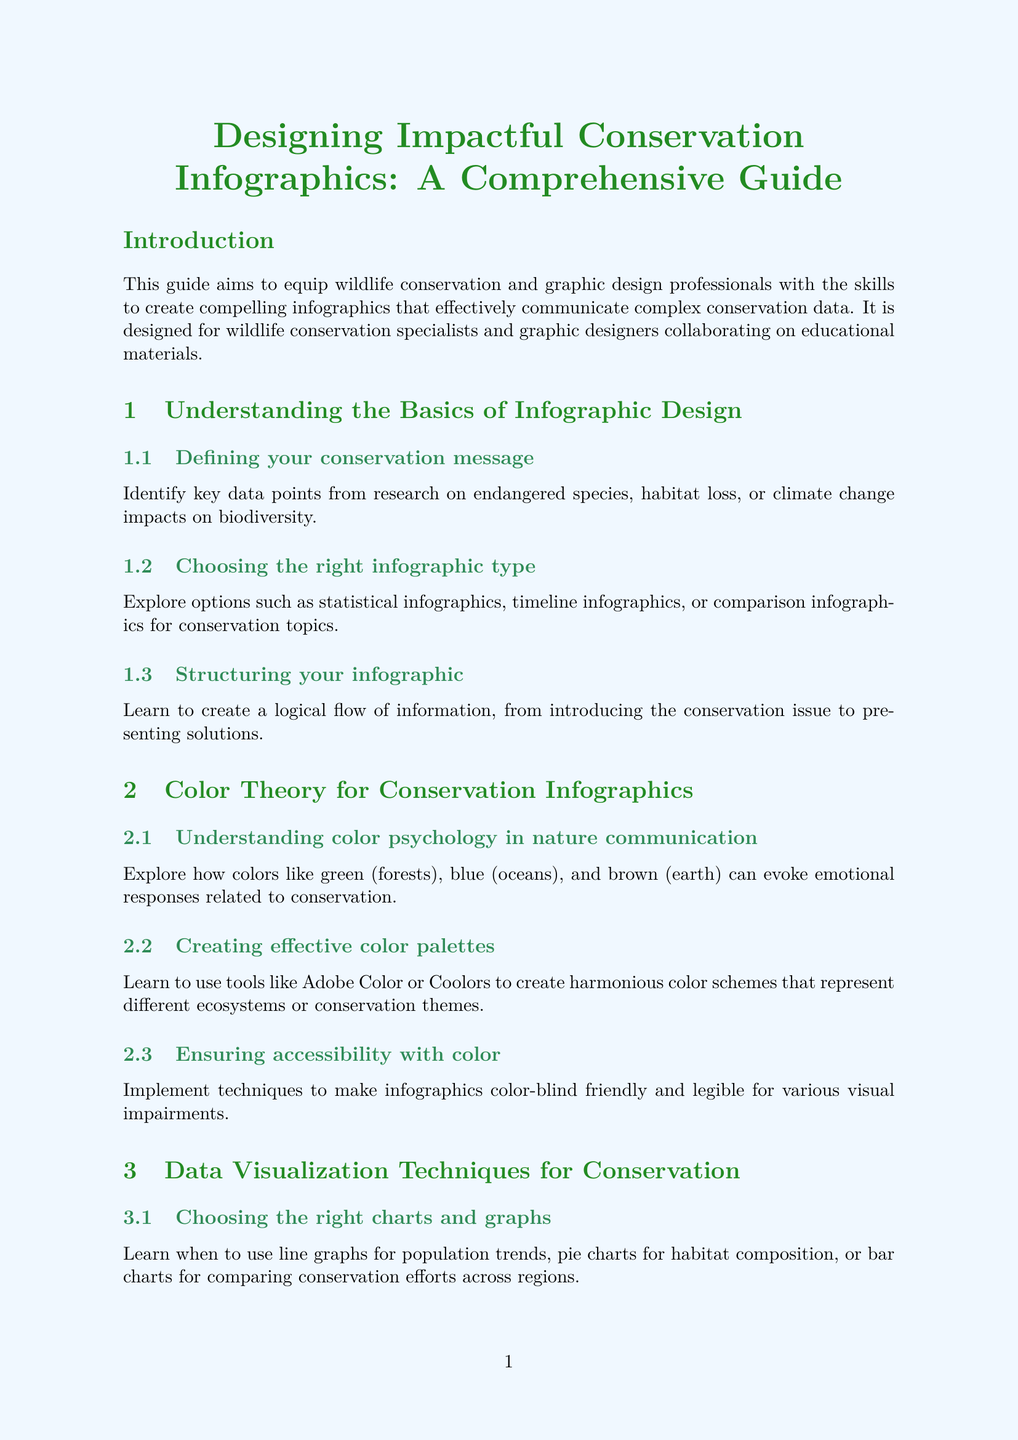What is the title of the manual? The title is stated at the beginning of the document.
Answer: Designing Impactful Conservation Infographics: A Comprehensive Guide Who is the target audience for this manual? The target audience is specified in the introduction section of the document.
Answer: Wildlife conservation specialists and graphic designers Which chapter discusses color psychology? This chapter can be located in the table of contents of the document.
Answer: Color Theory for Conservation Infographics What software is recommended for creating scalable graphics? The section is specifically dedicated to tools and software for infographic creation.
Answer: Adobe Illustrator Which principle is emphasized for balancing text and images? The relevant content is found in the layout and composition chapter.
Answer: Rule of thirds What is the focus of the case study on IUCN? This focus is briefly described in the case studies section of the document.
Answer: Species conservation status How many sections are there in the "Data Visualization Techniques for Conservation" chapter? This can be counted by looking at the sections under this chapter.
Answer: Three Which color is associated with forests in color psychology? The specific colors are listed in the color theory section of the document.
Answer: Green 